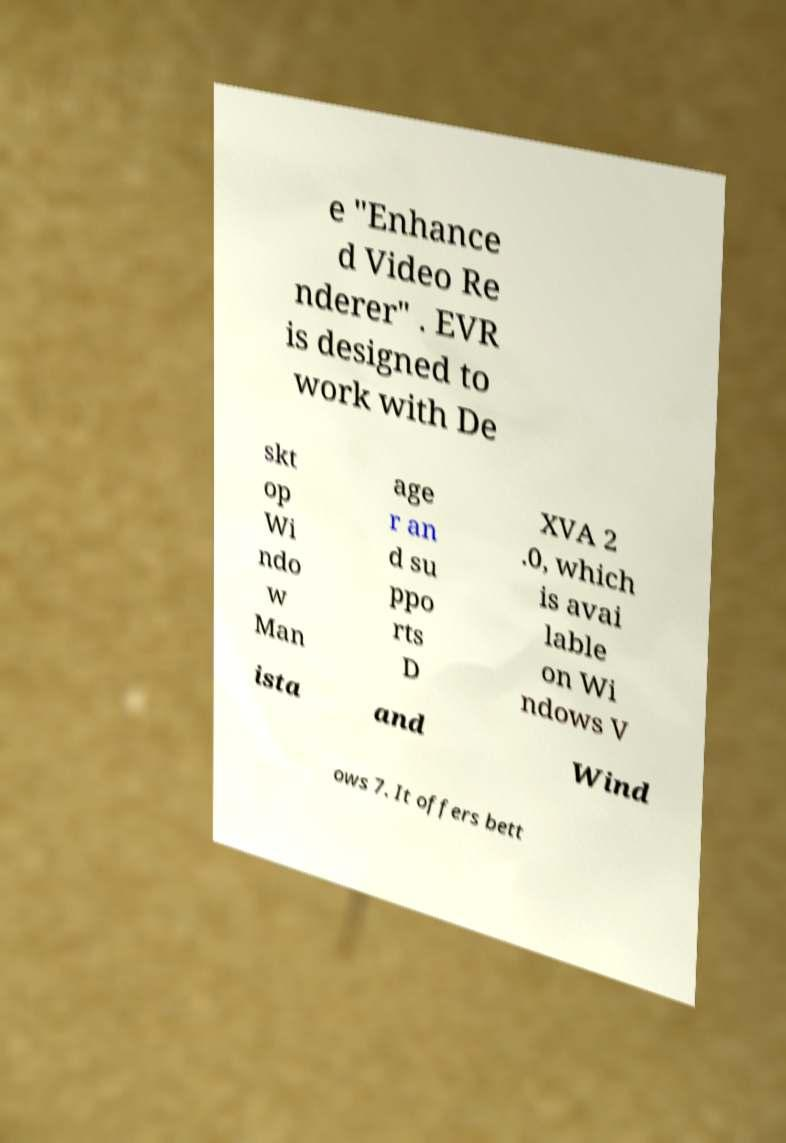Could you extract and type out the text from this image? e "Enhance d Video Re nderer" . EVR is designed to work with De skt op Wi ndo w Man age r an d su ppo rts D XVA 2 .0, which is avai lable on Wi ndows V ista and Wind ows 7. It offers bett 